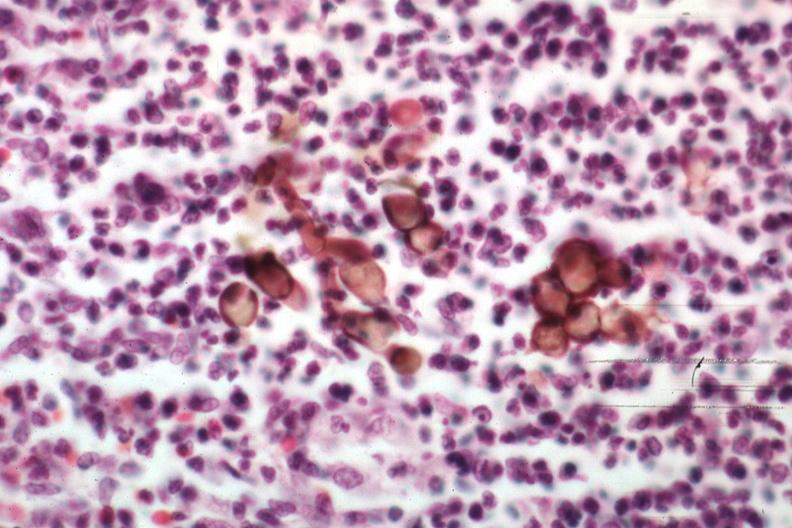s lip present?
Answer the question using a single word or phrase. No 